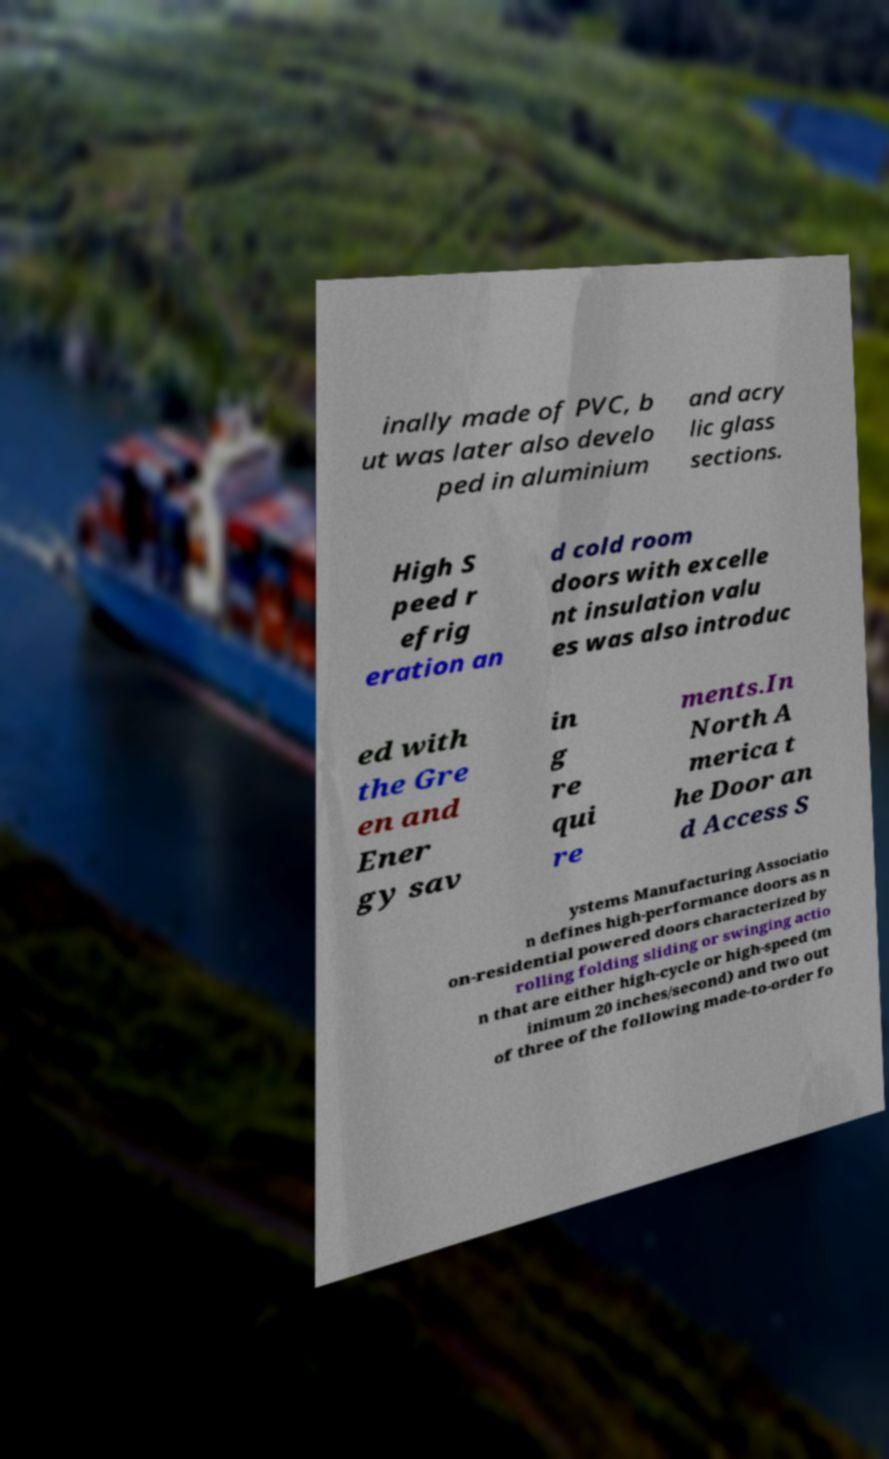Could you extract and type out the text from this image? inally made of PVC, b ut was later also develo ped in aluminium and acry lic glass sections. High S peed r efrig eration an d cold room doors with excelle nt insulation valu es was also introduc ed with the Gre en and Ener gy sav in g re qui re ments.In North A merica t he Door an d Access S ystems Manufacturing Associatio n defines high-performance doors as n on-residential powered doors characterized by rolling folding sliding or swinging actio n that are either high-cycle or high-speed (m inimum 20 inches/second) and two out of three of the following made-to-order fo 